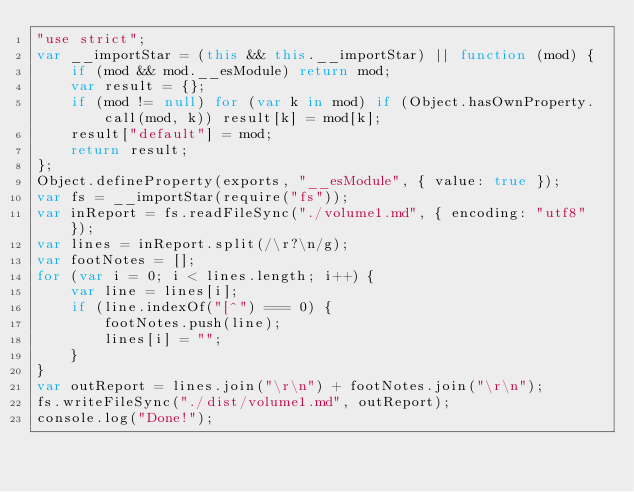<code> <loc_0><loc_0><loc_500><loc_500><_JavaScript_>"use strict";
var __importStar = (this && this.__importStar) || function (mod) {
    if (mod && mod.__esModule) return mod;
    var result = {};
    if (mod != null) for (var k in mod) if (Object.hasOwnProperty.call(mod, k)) result[k] = mod[k];
    result["default"] = mod;
    return result;
};
Object.defineProperty(exports, "__esModule", { value: true });
var fs = __importStar(require("fs"));
var inReport = fs.readFileSync("./volume1.md", { encoding: "utf8" });
var lines = inReport.split(/\r?\n/g);
var footNotes = [];
for (var i = 0; i < lines.length; i++) {
    var line = lines[i];
    if (line.indexOf("[^") === 0) {
        footNotes.push(line);
        lines[i] = "";
    }
}
var outReport = lines.join("\r\n") + footNotes.join("\r\n");
fs.writeFileSync("./dist/volume1.md", outReport);
console.log("Done!");
</code> 